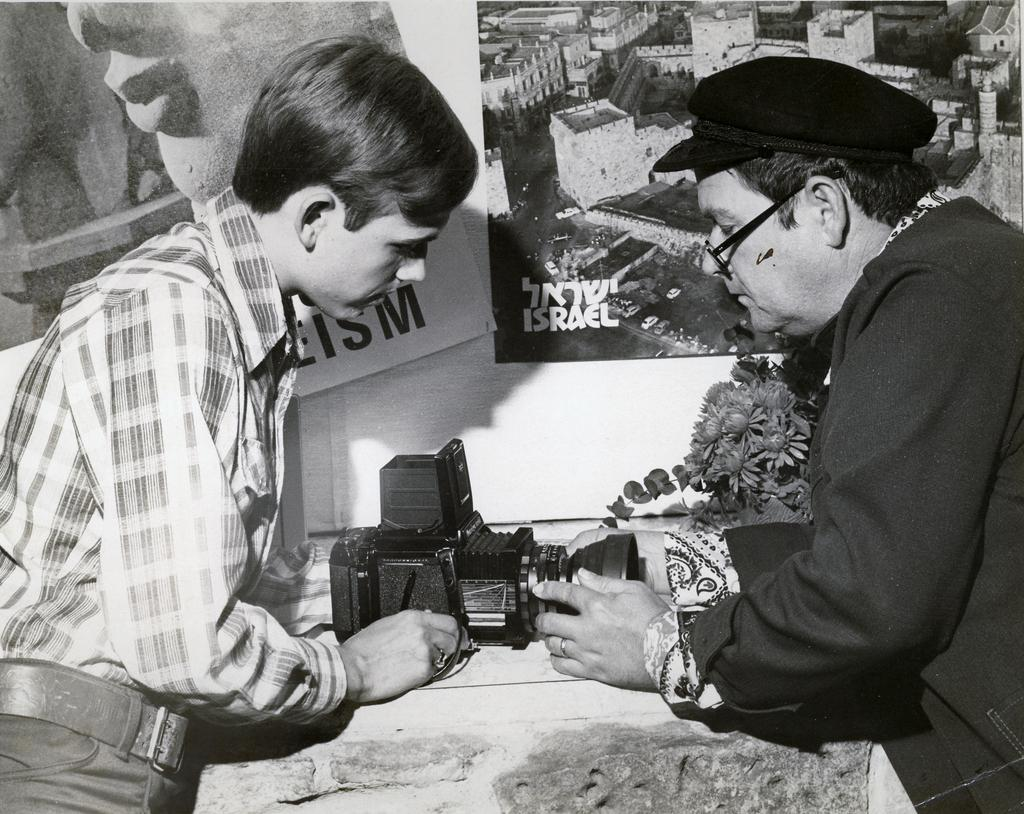How many people are in the image? There are two persons standing opposite to each other in the image. What object is present in the image that is used for recording videos? There is a video camera in the image. What can be seen on the wall in the image? There is a poster on the wall in the image. What type of snail can be seen crawling on the poster in the image? There is no snail present in the image, and therefore no such activity can be observed. 